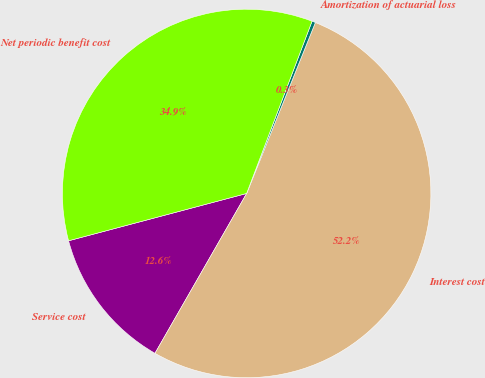<chart> <loc_0><loc_0><loc_500><loc_500><pie_chart><fcel>Service cost<fcel>Interest cost<fcel>Amortization of actuarial loss<fcel>Net periodic benefit cost<nl><fcel>12.58%<fcel>52.2%<fcel>0.31%<fcel>34.91%<nl></chart> 